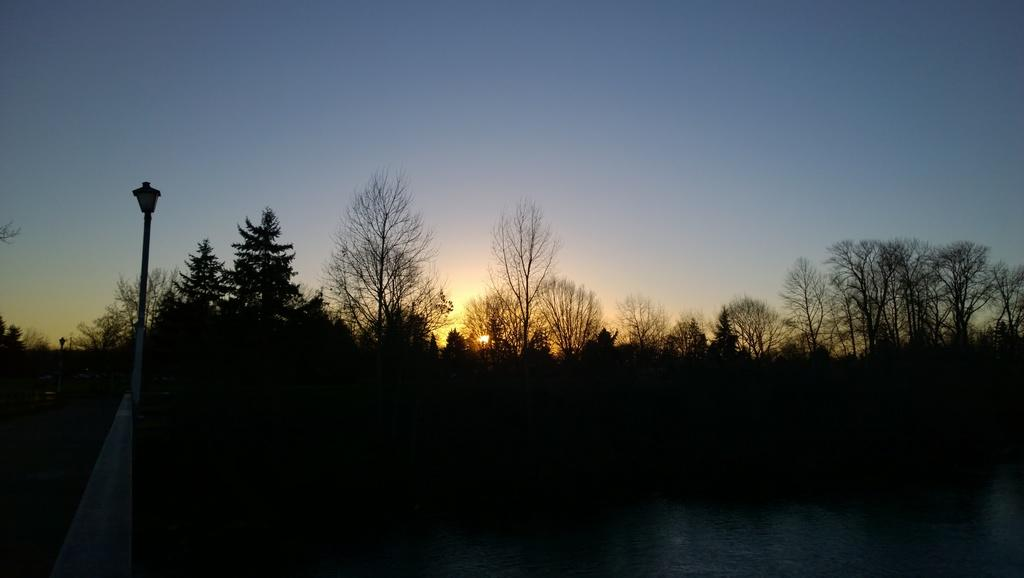What is located in front of the image? There is water in front of the image. What type of vegetation can be seen in the image? There are trees in the image. What structures are on the left side of the image? There are light poles on the left side of the image. What celestial body is visible in the sky in the background of the image? The sun is visible in the sky in the background of the image. Can you tell me how many pears are being used in the image? There are no pears present in the image. What type of snail can be seen crawling on the light poles in the image? There are no snails present in the image; the light poles are stationary structures. 